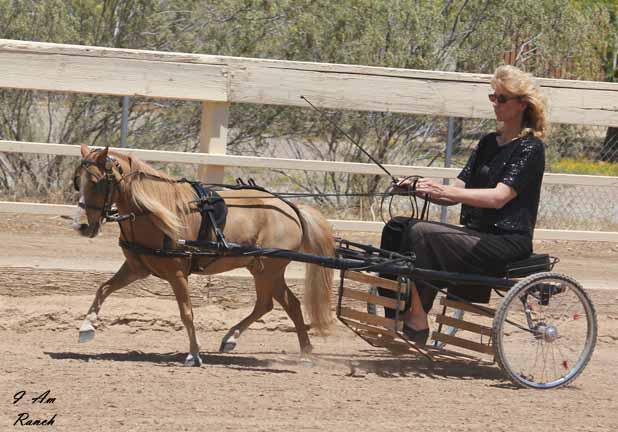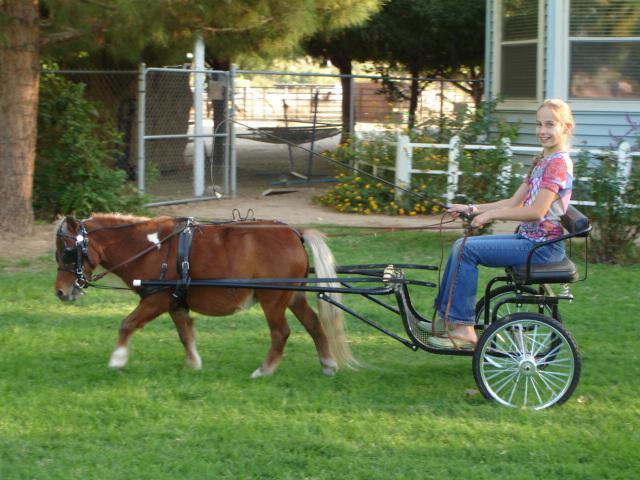The first image is the image on the left, the second image is the image on the right. Analyze the images presented: Is the assertion "There is one human being pulled by a horse facing right." valid? Answer yes or no. No. The first image is the image on the left, the second image is the image on the right. Examine the images to the left and right. Is the description "There are two humans riding a horse carriage in one of the images." accurate? Answer yes or no. No. 